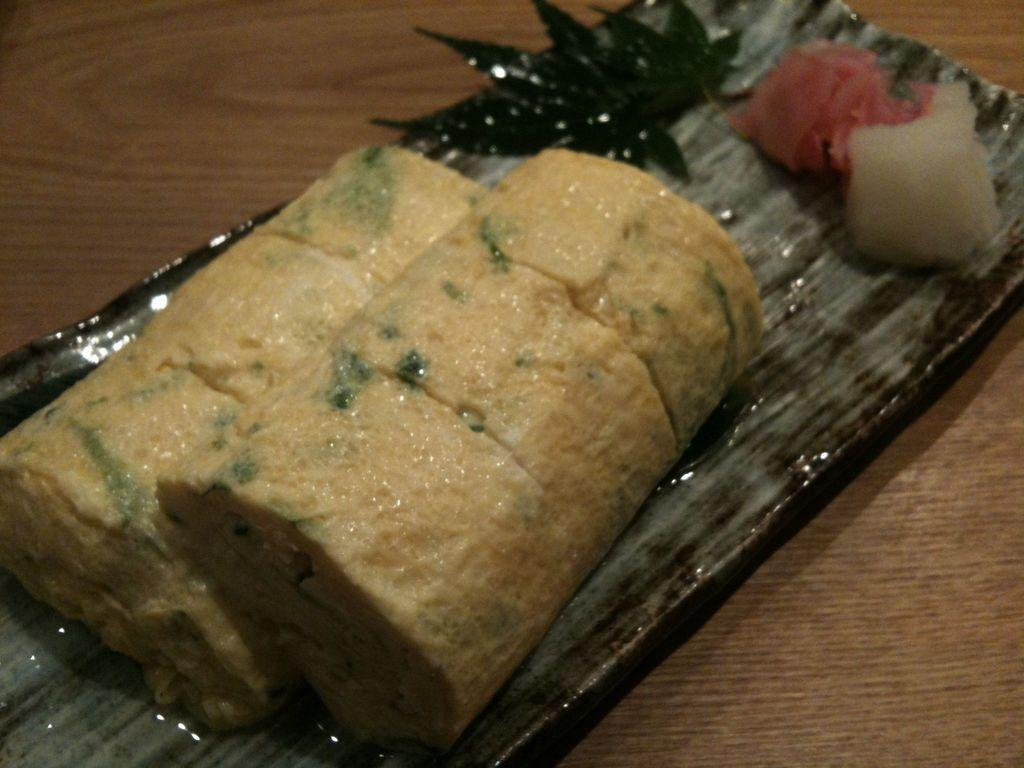What is on the tray that is visible in the image? There is a food item on a tray in the image. What is the tray placed on in the image? The tray is on a wooden surface. Where is this scene located in the image? This scene is in the foreground of the image. How does the snow affect the food item on the tray in the image? There is no snow present in the image, so it does not affect the food item on the tray. What type of knee is visible in the image? There is no knee present in the image. 